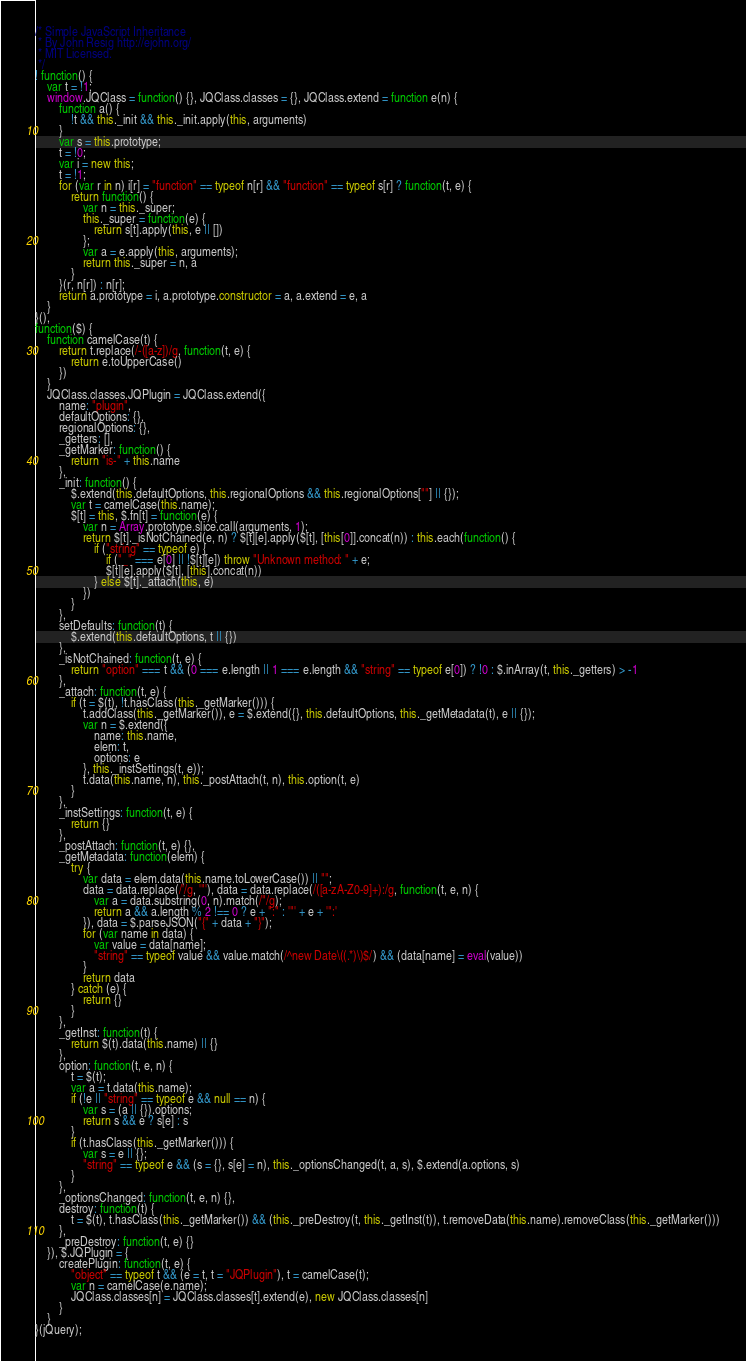Convert code to text. <code><loc_0><loc_0><loc_500><loc_500><_JavaScript_>/* Simple JavaScript Inheritance
 * By John Resig http://ejohn.org/
 * MIT Licensed.
 */
! function() {
    var t = !1;
    window.JQClass = function() {}, JQClass.classes = {}, JQClass.extend = function e(n) {
        function a() {
            !t && this._init && this._init.apply(this, arguments)
        }
        var s = this.prototype;
        t = !0;
        var i = new this;
        t = !1;
        for (var r in n) i[r] = "function" == typeof n[r] && "function" == typeof s[r] ? function(t, e) {
            return function() {
                var n = this._super;
                this._super = function(e) {
                    return s[t].apply(this, e || [])
                };
                var a = e.apply(this, arguments);
                return this._super = n, a
            }
        }(r, n[r]) : n[r];
        return a.prototype = i, a.prototype.constructor = a, a.extend = e, a
    }
}(),
function($) {
    function camelCase(t) {
        return t.replace(/-([a-z])/g, function(t, e) {
            return e.toUpperCase()
        })
    }
    JQClass.classes.JQPlugin = JQClass.extend({
        name: "plugin",
        defaultOptions: {},
        regionalOptions: {},
        _getters: [],
        _getMarker: function() {
            return "is-" + this.name
        },
        _init: function() {
            $.extend(this.defaultOptions, this.regionalOptions && this.regionalOptions[""] || {});
            var t = camelCase(this.name);
            $[t] = this, $.fn[t] = function(e) {
                var n = Array.prototype.slice.call(arguments, 1);
                return $[t]._isNotChained(e, n) ? $[t][e].apply($[t], [this[0]].concat(n)) : this.each(function() {
                    if ("string" == typeof e) {
                        if ("_" === e[0] || !$[t][e]) throw "Unknown method: " + e;
                        $[t][e].apply($[t], [this].concat(n))
                    } else $[t]._attach(this, e)
                })
            }
        },
        setDefaults: function(t) {
            $.extend(this.defaultOptions, t || {})
        },
        _isNotChained: function(t, e) {
            return "option" === t && (0 === e.length || 1 === e.length && "string" == typeof e[0]) ? !0 : $.inArray(t, this._getters) > -1
        },
        _attach: function(t, e) {
            if (t = $(t), !t.hasClass(this._getMarker())) {
                t.addClass(this._getMarker()), e = $.extend({}, this.defaultOptions, this._getMetadata(t), e || {});
                var n = $.extend({
                    name: this.name,
                    elem: t,
                    options: e
                }, this._instSettings(t, e));
                t.data(this.name, n), this._postAttach(t, n), this.option(t, e)
            }
        },
        _instSettings: function(t, e) {
            return {}
        },
        _postAttach: function(t, e) {},
        _getMetadata: function(elem) {
            try {
                var data = elem.data(this.name.toLowerCase()) || "";
                data = data.replace(/'/g, '"'), data = data.replace(/([a-zA-Z0-9]+):/g, function(t, e, n) {
                    var a = data.substring(0, n).match(/"/g);
                    return a && a.length % 2 !== 0 ? e + ":" : '"' + e + '":'
                }), data = $.parseJSON("{" + data + "}");
                for (var name in data) {
                    var value = data[name];
                    "string" == typeof value && value.match(/^new Date\((.*)\)$/) && (data[name] = eval(value))
                }
                return data
            } catch (e) {
                return {}
            }
        },
        _getInst: function(t) {
            return $(t).data(this.name) || {}
        },
        option: function(t, e, n) {
            t = $(t);
            var a = t.data(this.name);
            if (!e || "string" == typeof e && null == n) {
                var s = (a || {}).options;
                return s && e ? s[e] : s
            }
            if (t.hasClass(this._getMarker())) {
                var s = e || {};
                "string" == typeof e && (s = {}, s[e] = n), this._optionsChanged(t, a, s), $.extend(a.options, s)
            }
        },
        _optionsChanged: function(t, e, n) {},
        destroy: function(t) {
            t = $(t), t.hasClass(this._getMarker()) && (this._preDestroy(t, this._getInst(t)), t.removeData(this.name).removeClass(this._getMarker()))
        },
        _preDestroy: function(t, e) {}
    }), $.JQPlugin = {
        createPlugin: function(t, e) {
            "object" == typeof t && (e = t, t = "JQPlugin"), t = camelCase(t);
            var n = camelCase(e.name);
            JQClass.classes[n] = JQClass.classes[t].extend(e), new JQClass.classes[n]
        }
    }
}(jQuery);</code> 